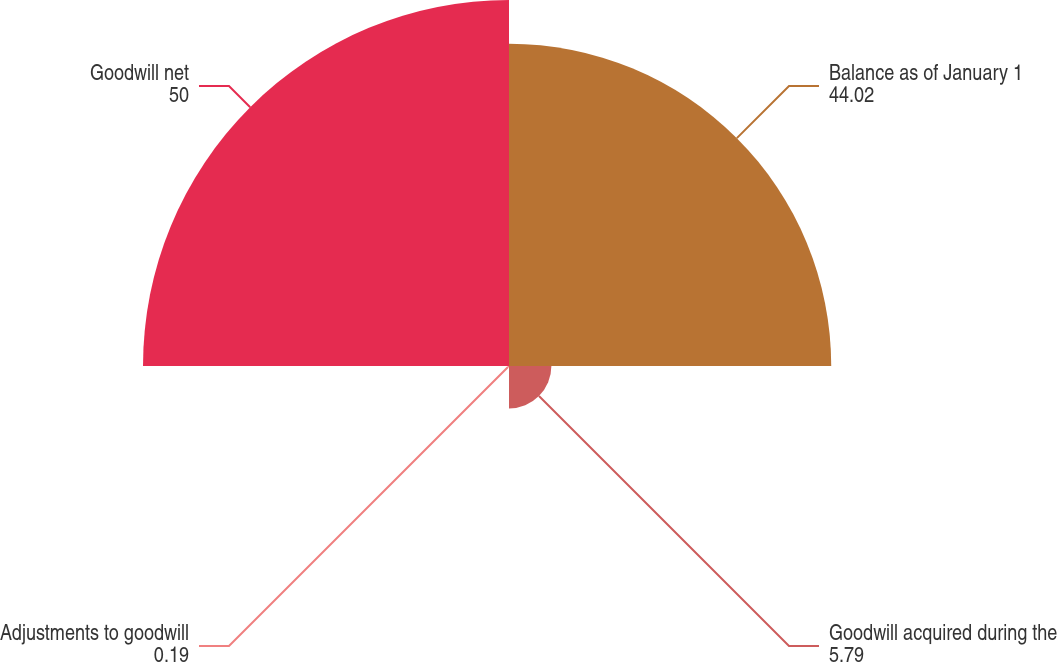Convert chart. <chart><loc_0><loc_0><loc_500><loc_500><pie_chart><fcel>Balance as of January 1<fcel>Goodwill acquired during the<fcel>Adjustments to goodwill<fcel>Goodwill net<nl><fcel>44.02%<fcel>5.79%<fcel>0.19%<fcel>50.0%<nl></chart> 